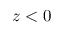Convert formula to latex. <formula><loc_0><loc_0><loc_500><loc_500>z < 0</formula> 